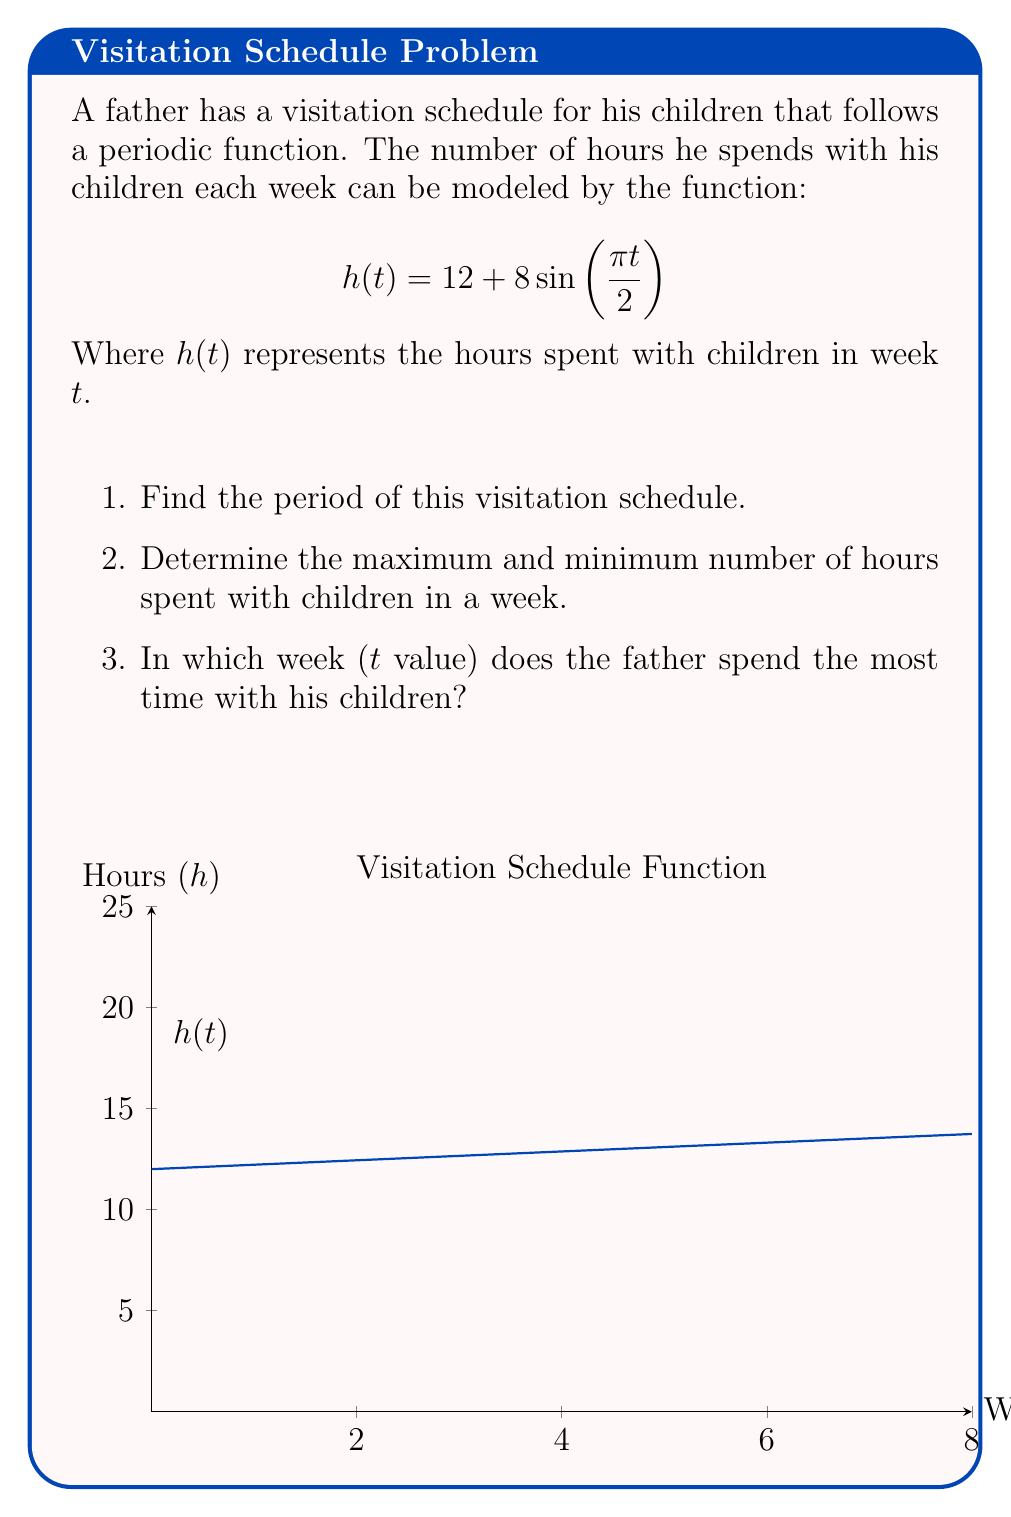Could you help me with this problem? Let's approach this step-by-step:

1) To find the period, we need to look at the sine function within $h(t)$:

   $$8\sin(\frac{\pi t}{2})$$

   The general form of a sine function is $A\sin(B(t-C))+D$, where $\frac{2\pi}{|B|}$ gives the period.
   
   Here, $B = \frac{\pi}{2}$, so the period is:
   
   $$\frac{2\pi}{|\frac{\pi}{2}|} = 4$$

   Therefore, the visitation schedule repeats every 4 weeks.

2) The function oscillates around 12 with an amplitude of 8. So:

   Maximum: $12 + 8 = 20$ hours
   Minimum: $12 - 8 = 4$ hours

3) The sine function reaches its maximum value when its argument is $\frac{\pi}{2}$ (or odd multiples of it). So we need to solve:

   $$\frac{\pi t}{2} = \frac{\pi}{2}$$

   $$t = 1$$

   Therefore, the father spends the most time with his children in week 1 (and every 4 weeks thereafter due to the periodicity).
Answer: 1) 4 weeks
2) Max: 20 hours, Min: 4 hours
3) Week 1 (and every 4 weeks thereafter) 